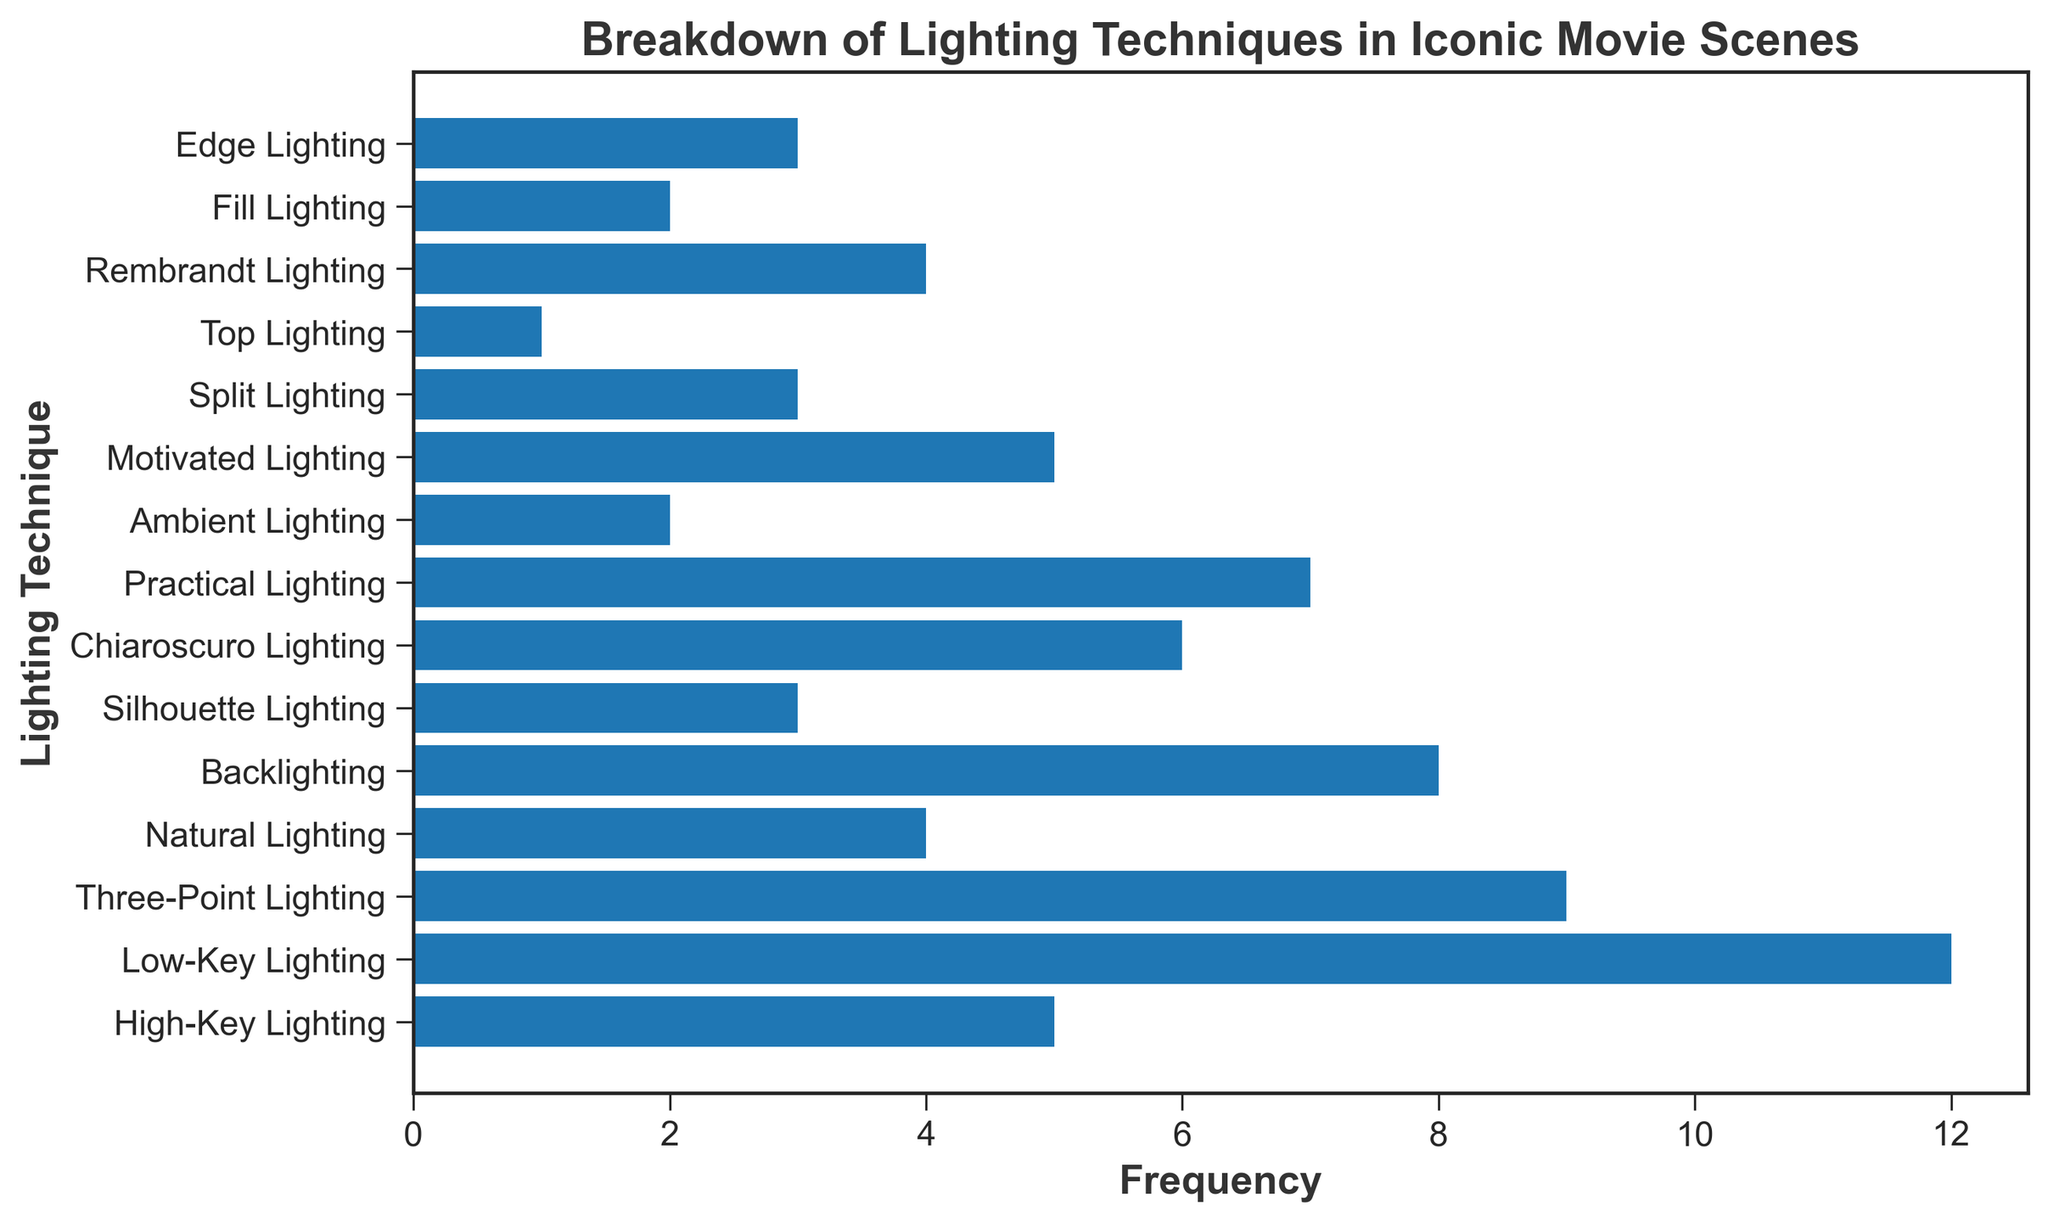What is the most frequently used lighting technique in iconic movie scenes? The figure shows the frequency of each lighting technique. The one with the highest bar is the most frequently used. Low-Key Lighting has the highest bar with a frequency of 12.
Answer: Low-Key Lighting What is the total frequency of High-Key Lighting and Chiaroscuro Lighting combined? To find the combined frequency, add the frequency of High-Key Lighting (5) and Chiaroscuro Lighting (6). 5 + 6 = 11
Answer: 11 Which lighting techniques have the same frequency of usage? By inspecting the height of the bars, we see that Silhouette Lighting, Split Lighting, and Edge Lighting each have a frequency of 3.
Answer: Silhouette Lighting, Split Lighting, Edge Lighting How many techniques have a usage frequency greater than 6? By examining the bars, the techniques with frequencies higher than 6 are Low-Key Lighting (12), Three-Point Lighting (9), Backlighting (8), Practical Lighting (7). So there are 4 techniques in total.
Answer: 4 Which lighting technique is used more frequently: Rembrandt Lighting or Natural Lighting? Compare the lengths of the bars for Rembrandt Lighting (4) and Natural Lighting (4). Both have the same bar lengths indicating they have equal usage frequencies.
Answer: Equal What is the average frequency of Natural Lighting, Rembrandt Lighting, and Fill Lighting combined? First, sum the frequencies of Natural Lighting, Rembrandt Lighting, and Fill Lighting. That's 4 + 4 + 2 = 10. Then, divide by the number of techniques, which is 3. So, the average is 10/3 ≈ 3.33.
Answer: 3.33 If we combine the frequencies of Silhouette Lighting, Edge Lighting, and Split Lighting, what is the logical comparison (greater, less, or equal) with the frequency of Three-Point Lighting? Calculate the combined frequency of Silhouette Lighting (3), Edge Lighting (3), and Split Lighting (3). That's 3 + 3 + 3 = 9. Three-Point Lighting has a frequency of 9. The frequencies are equal.
Answer: Equal Which lighting technique is used the least in iconic movie scenes? By inspecting the shortest bar, we identify Top Lighting with a frequency of 1 as the least used technique.
Answer: Top Lighting 